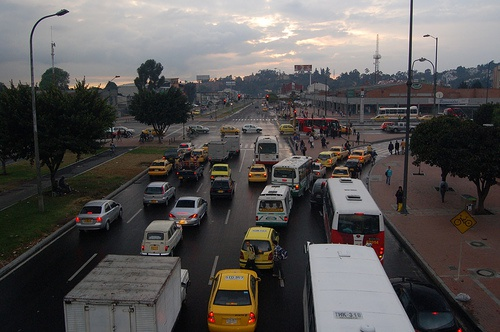Describe the objects in this image and their specific colors. I can see truck in darkgray, gray, and black tones, bus in darkgray, black, gray, and maroon tones, car in darkgray, black, gray, and maroon tones, bus in darkgray, black, gray, and maroon tones, and car in darkgray, black, olive, and maroon tones in this image. 